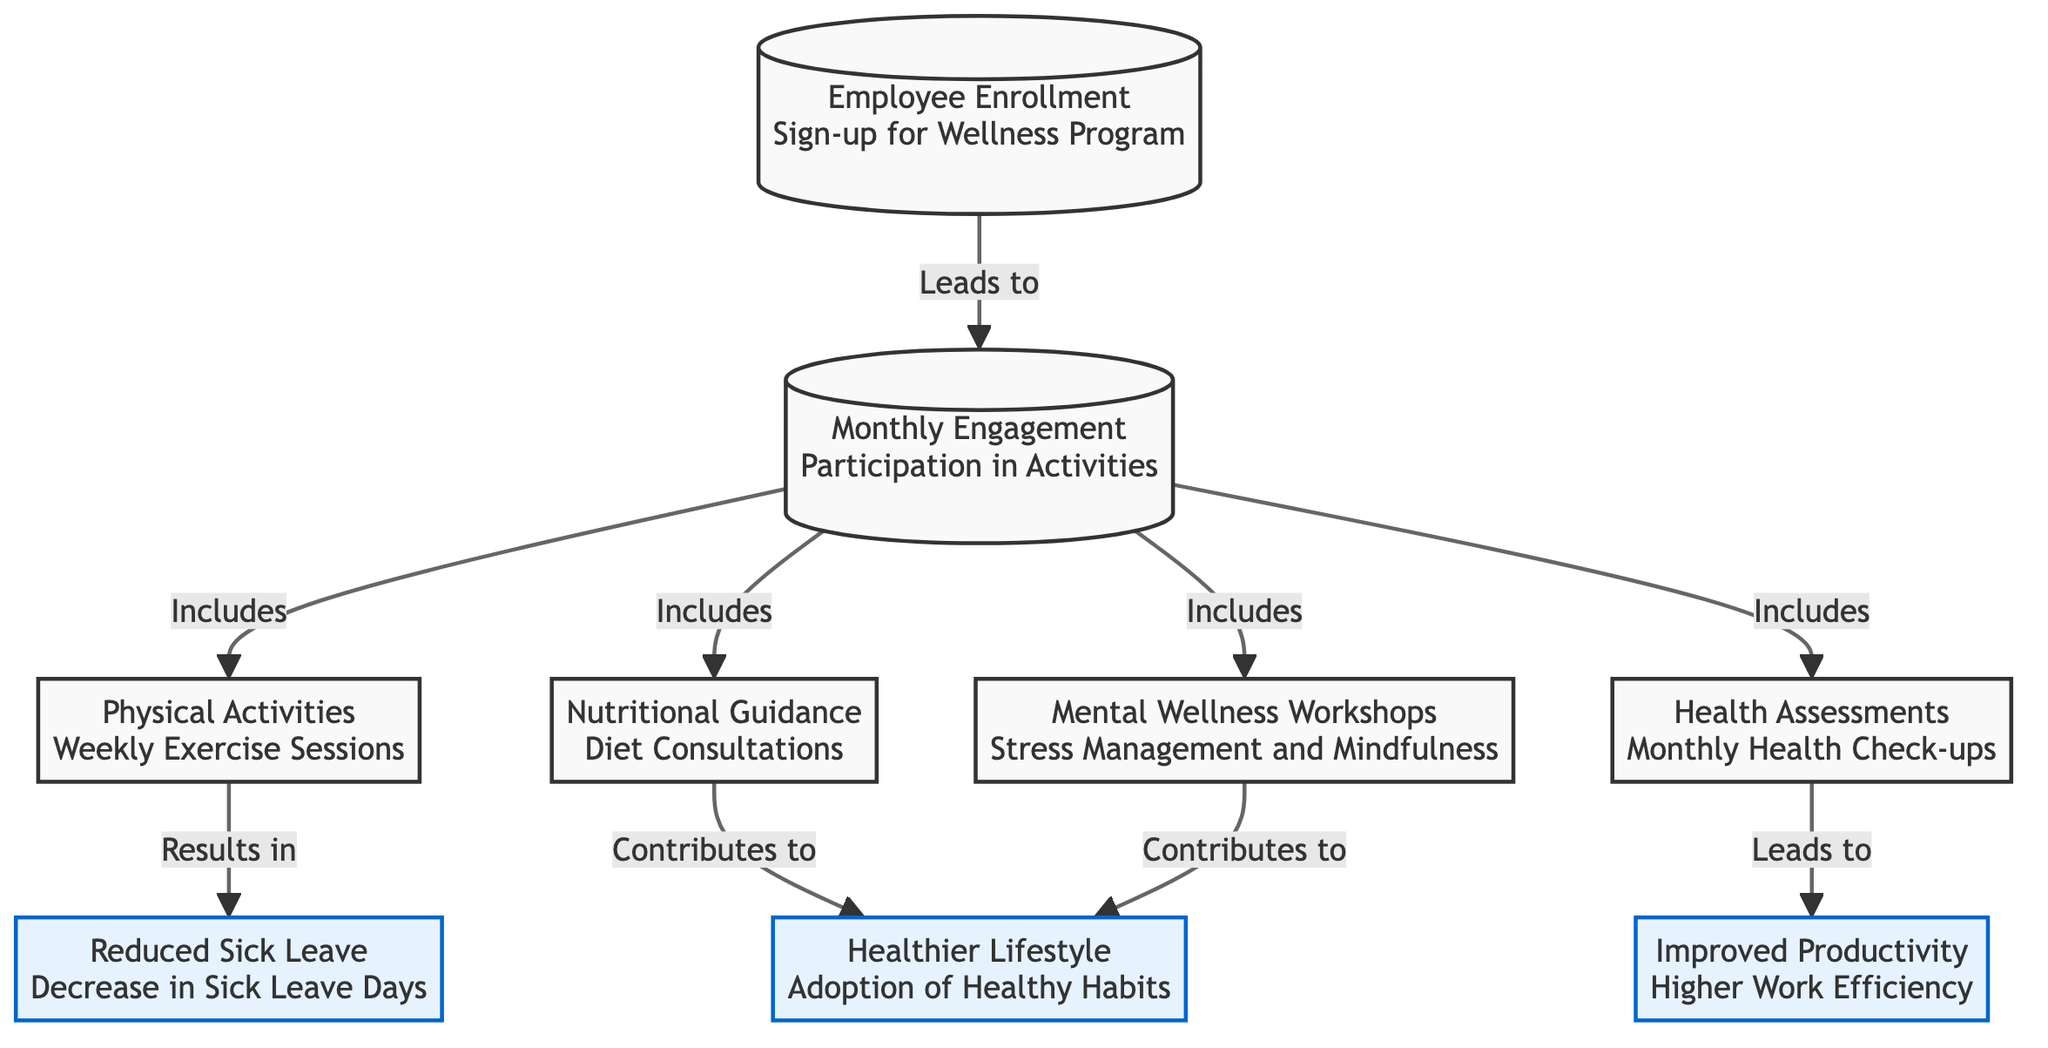What is the starting point of the flowchart? The starting point is Node 1, which is labeled "Employee Enrollment Sign-up for Wellness Program." This is the first step in the process, indicating where employees enter the wellness program.
Answer: Employee Enrollment Sign-up for Wellness Program How many activities are included in the Monthly Engagement? By examining Node 2, which states "Monthly Engagement," there are four distinct activities listed in the nodes branching from it: Physical Activities, Nutritional Guidance, Mental Wellness Workshops, and Health Assessments. Thus, the total number is four activities included.
Answer: 4 Which node contributes to both Healthier Lifestyle and Improved Productivity? By analyzing the connections, both Nutritional Guidance and Mental Wellness Workshops (Nodes 4 and 5) link directly to the Healthier Lifestyle node. However, the only activity contributing to Improved Productivity is Health Assessments (Node 6). Therefore, the answer is that there's no single node contributing to both; they are separate.
Answer: No single node What is the outcome linked to Physical Activities? From Node 3, which pertains to Physical Activities, the flow indicates it results in the outcome of Reduced Sick Leave, shown in Node 7. This is the direct consequence related to involvement in Physical Activities.
Answer: Reduced Sick Leave Which aspect of wellness has the most direct link to increased work efficiency? Following the diagram’s flow, the node that leads directly to Improved Productivity is Node 6, Health Assessments, suggesting that participation in these monthly check-ups correlates most closely with higher work efficiency.
Answer: Health Assessments Which activities lead to a Healthier Lifestyle? By checking the connections from Monthly Engagement (Node 2), both Nutritional Guidance and Mental Wellness Workshops lead to a Healthier Lifestyle. Thus, participation in these two activities contributes to adopting healthier habits in employees' lives.
Answer: Nutritional Guidance, Mental Wellness Workshops How many outcome nodes are present in the diagram? The diagram contains three outcome nodes: Reduced Sick Leave, Improved Productivity, and Healthier Lifestyle, which are clearly marked as outcomes in the flowchart. Thus, the total number of outcome nodes is three.
Answer: 3 What is the relationship between Nutritional Guidance and Healthier Lifestyle? Nutritional Guidance, identified in Node 4, contributes to Healthier Lifestyle, as illustrated by the direct connection from Nutritional Guidance to the Healthier Lifestyle outcome node. This highlights how dietary guidance impacts overall wellness.
Answer: Contributes to Which node indicates a decrease in sick leave days? The outcome node specifically referencing a decrease in sick leave days is Node 7, labeled "Reduced Sick Leave." This node represents the result of participating in the wellness program activities.
Answer: Reduced Sick Leave 